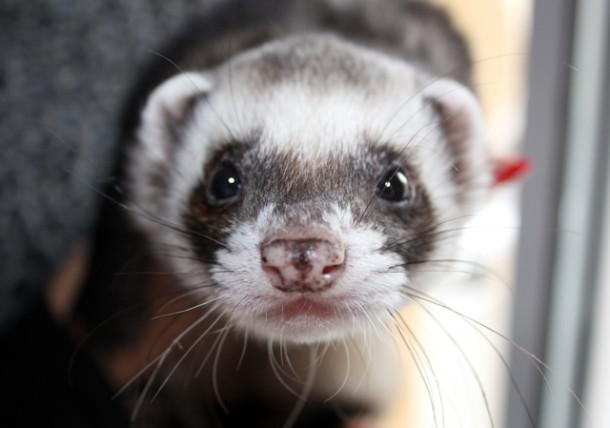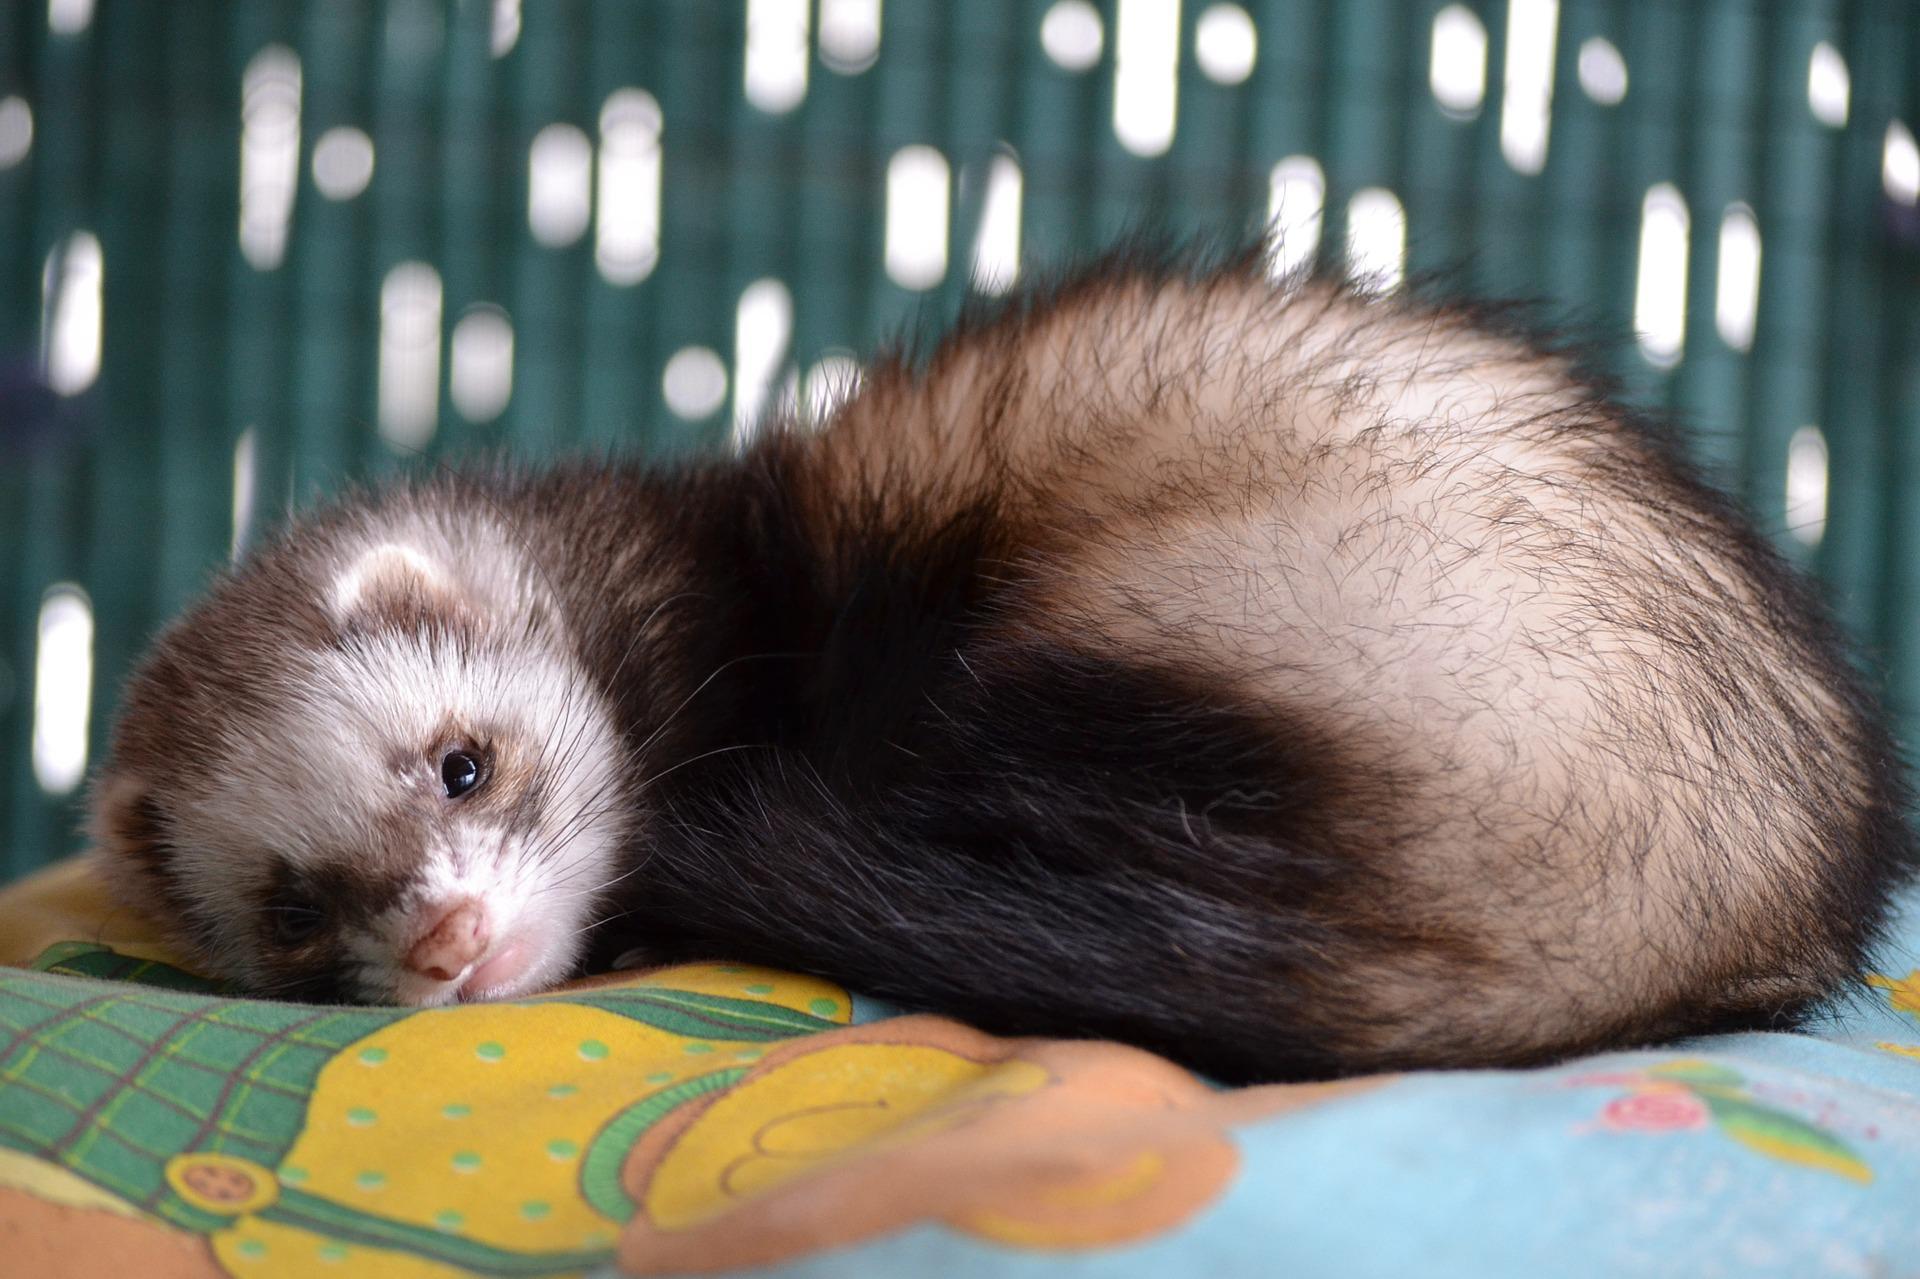The first image is the image on the left, the second image is the image on the right. For the images shown, is this caption "at least one animal has its mouth open" true? Answer yes or no. No. 